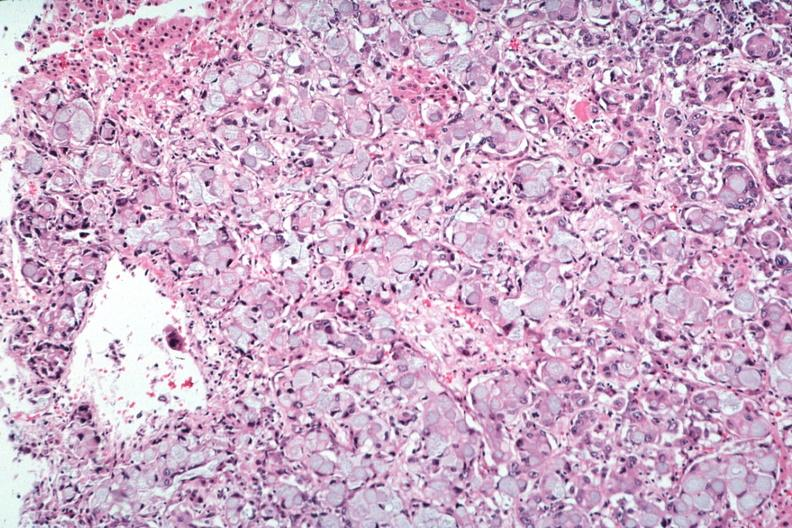what is present?
Answer the question using a single word or phrase. Adrenal 